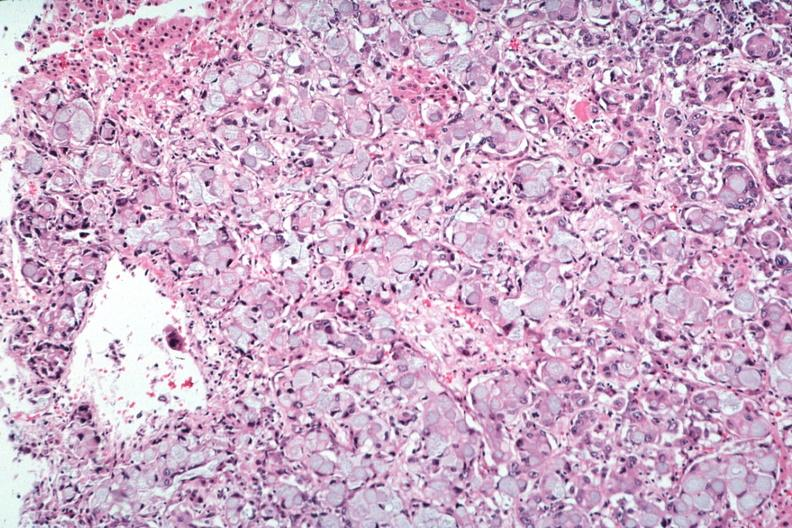what is present?
Answer the question using a single word or phrase. Adrenal 